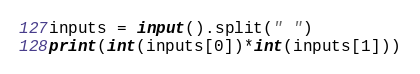<code> <loc_0><loc_0><loc_500><loc_500><_Python_>inputs = input().split(" ")
print(int(inputs[0])*int(inputs[1]))</code> 